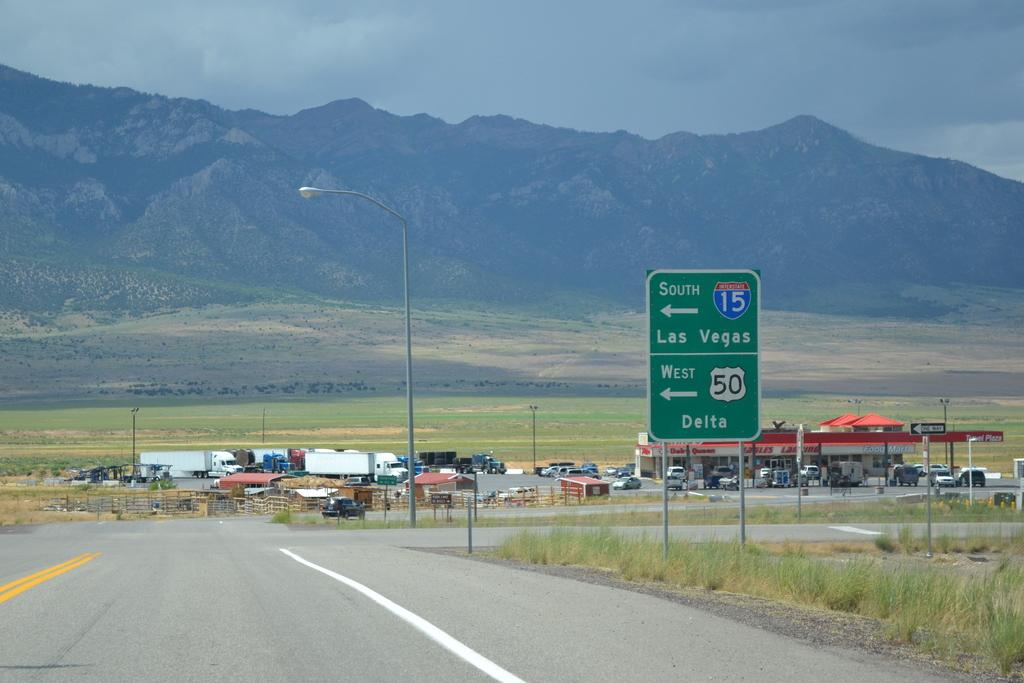<image>
Write a terse but informative summary of the picture. A shot on a highway interesection of interstate 15 south with a gas station in the distance 